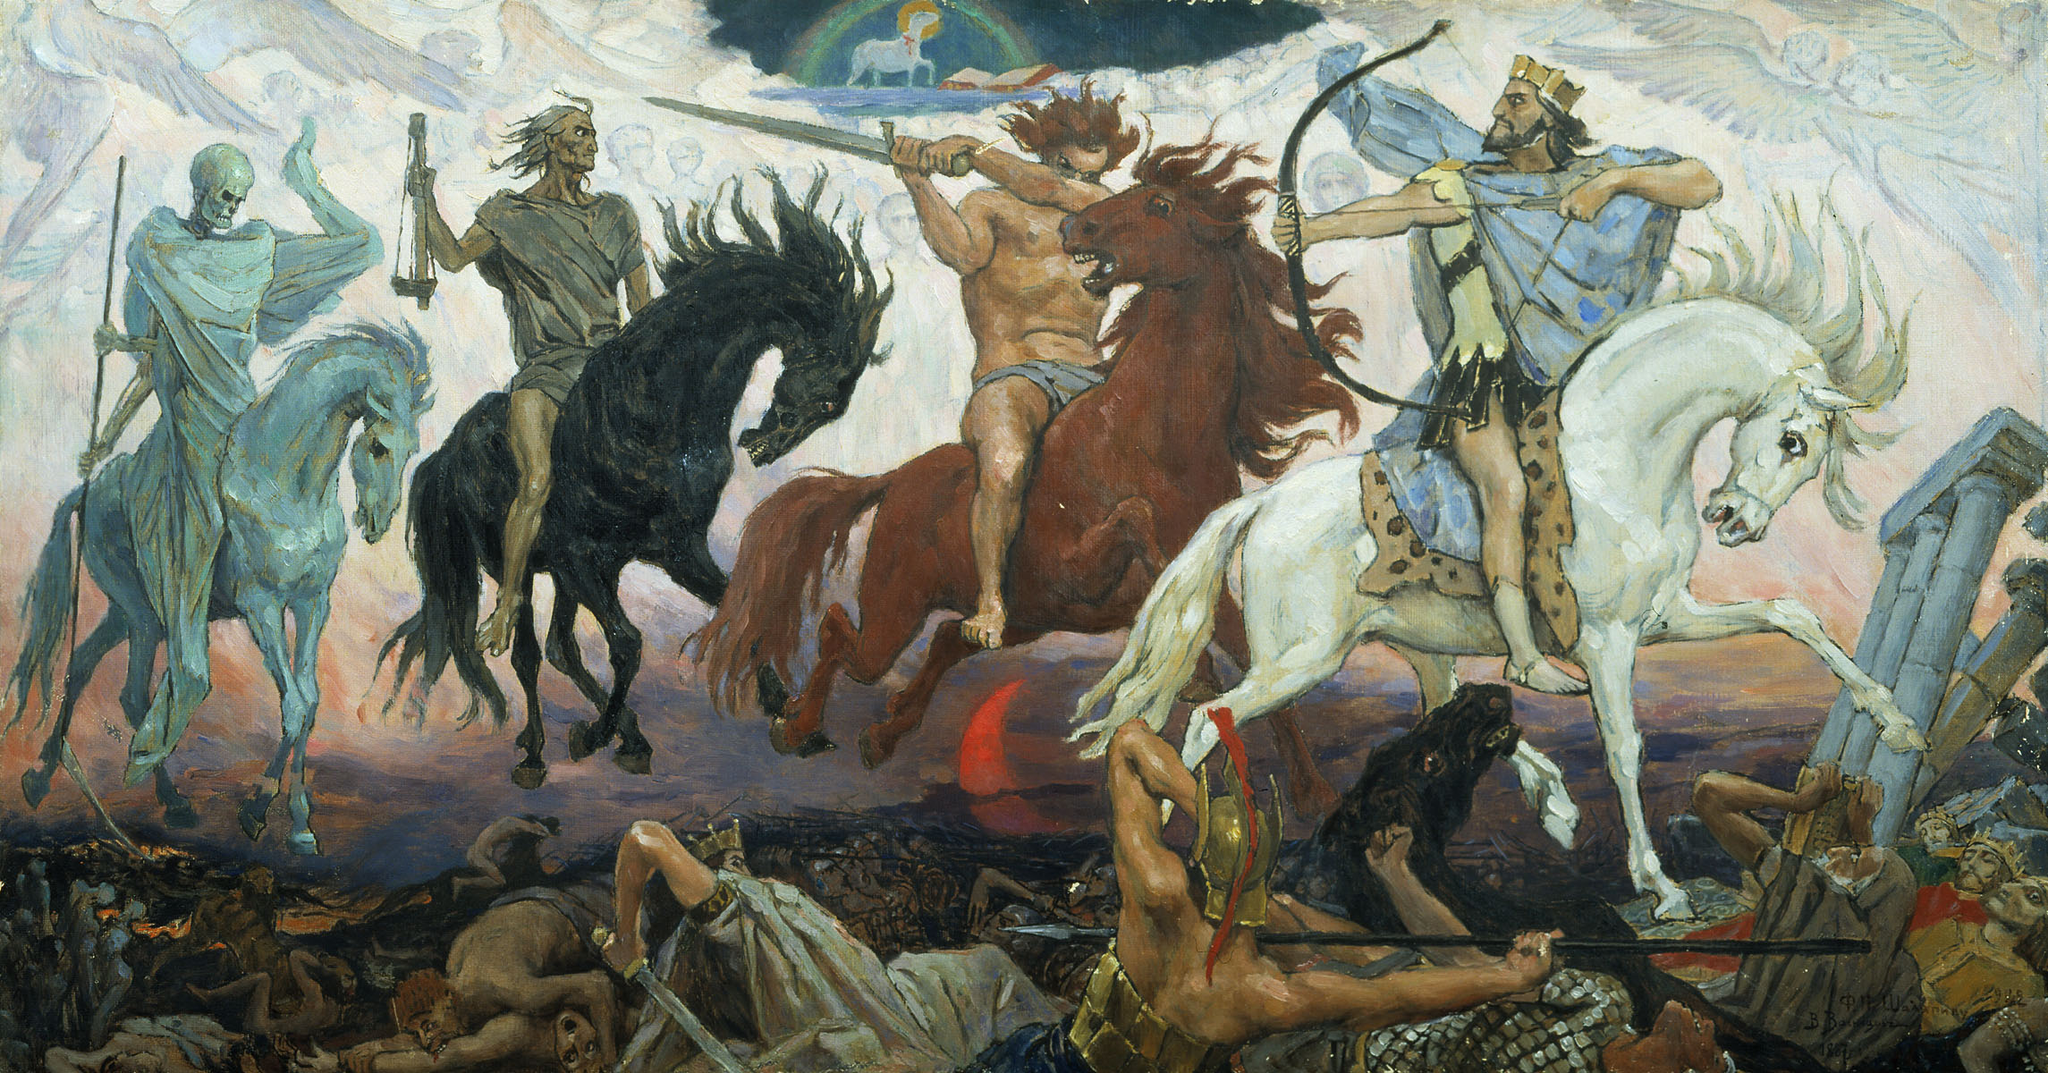If these horsemen were depicted as guardians of peace rather than harbingers of doom, how might they appear? Transformed into guardians of peace, the Four Horsemen would take on a benevolent and serene appearance. Conquest, now a symbol of unity, rides a white horse adorned with olive branches, wielding a banner of international cooperation. War, reimagined as a protector, sits atop a red horse with armor that glows softly, turning weapons into tools for rebuilding and defense. Famine, as an emblem of sustenance, rides a black horse that gallops amidst fields of golden crops, holding a cornucopia spilling over with abundance. Death, transformed into a symbol of renewal, rides a pale horse surrounded by flourishing flora, bringing the cycle of rebirth. Their serene expressions and harmonious presence reflect their roles as guardians, with their powers directed towards fostering peace and prosperity instead of chaos and destruction. 